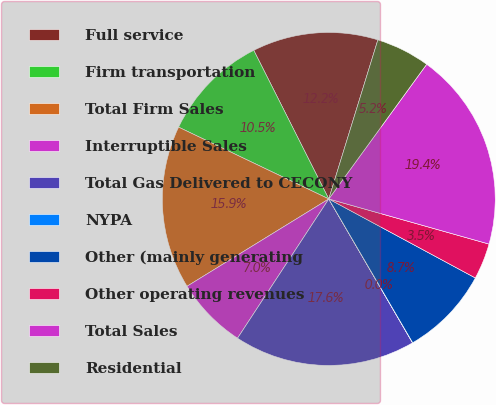Convert chart. <chart><loc_0><loc_0><loc_500><loc_500><pie_chart><fcel>Full service<fcel>Firm transportation<fcel>Total Firm Sales<fcel>Interruptible Sales<fcel>Total Gas Delivered to CECONY<fcel>NYPA<fcel>Other (mainly generating<fcel>Other operating revenues<fcel>Total Sales<fcel>Residential<nl><fcel>12.2%<fcel>10.46%<fcel>15.88%<fcel>6.98%<fcel>17.62%<fcel>0.02%<fcel>8.72%<fcel>3.5%<fcel>19.36%<fcel>5.24%<nl></chart> 